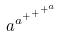<formula> <loc_0><loc_0><loc_500><loc_500>a ^ { a ^ { + ^ { + ^ { + ^ { a } } } } }</formula> 